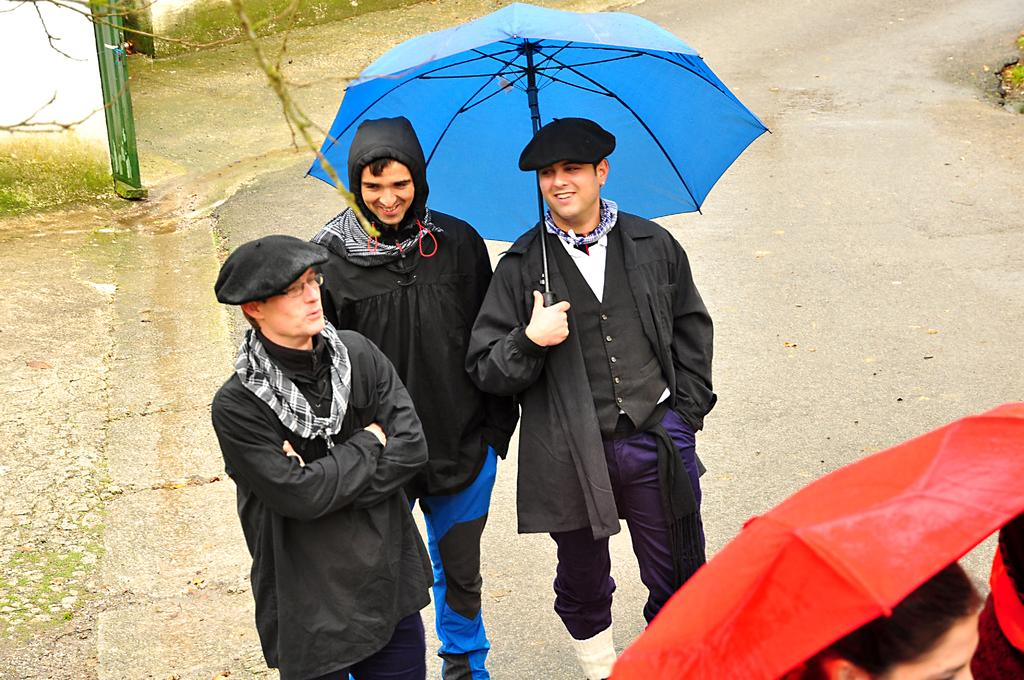What can be seen in the image? There are men in the image. Where are the men located? The men are standing on the road. What is one of the men holding? One of the men is holding an umbrella. What type of pickle is the man holding in the image? There is no pickle present in the image; one of the men is holding an umbrella. 